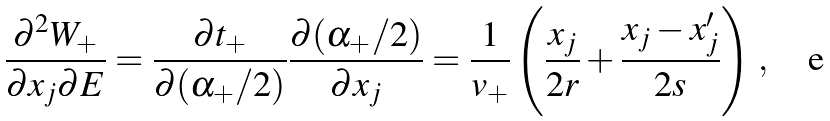<formula> <loc_0><loc_0><loc_500><loc_500>\frac { \partial ^ { 2 } W _ { + } } { \partial x _ { j } \partial E } = \frac { \partial t _ { + } } { \partial ( \alpha _ { + } / 2 ) } \frac { \partial ( \alpha _ { + } / 2 ) } { \partial x _ { j } } = \frac { 1 } { v _ { + } } \left ( \frac { x _ { j } } { 2 r } + \frac { x _ { j } - x _ { j } ^ { \prime } } { 2 s } \right ) \, ,</formula> 